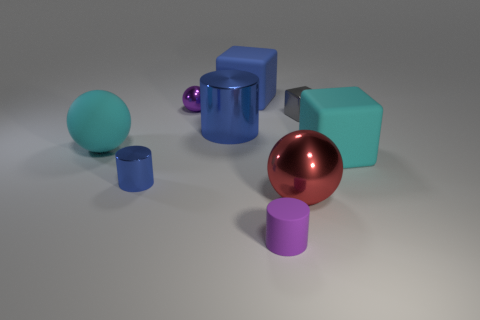The tiny object that is the same color as the tiny shiny sphere is what shape?
Keep it short and to the point. Cylinder. What number of objects are either blue things or small gray objects behind the cyan block?
Make the answer very short. 4. The tiny thing that is both left of the small purple rubber thing and in front of the big blue shiny object has what shape?
Give a very brief answer. Cylinder. The ball that is in front of the matte object that is on the right side of the small purple cylinder is made of what material?
Give a very brief answer. Metal. Are the tiny cube in front of the big blue rubber thing and the large blue cube made of the same material?
Provide a short and direct response. No. There is a matte cube on the left side of the small purple cylinder; what size is it?
Offer a terse response. Large. Are there any big blue cubes that are right of the tiny cylinder to the right of the small purple metallic object?
Offer a terse response. No. Does the cube that is behind the purple metal ball have the same color as the large metallic thing that is behind the big red ball?
Provide a succinct answer. Yes. The rubber cylinder has what color?
Make the answer very short. Purple. Is there any other thing that has the same color as the rubber sphere?
Offer a terse response. Yes. 